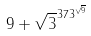Convert formula to latex. <formula><loc_0><loc_0><loc_500><loc_500>9 + \sqrt { 3 } ^ { 3 7 3 ^ { \sqrt { 9 } } }</formula> 